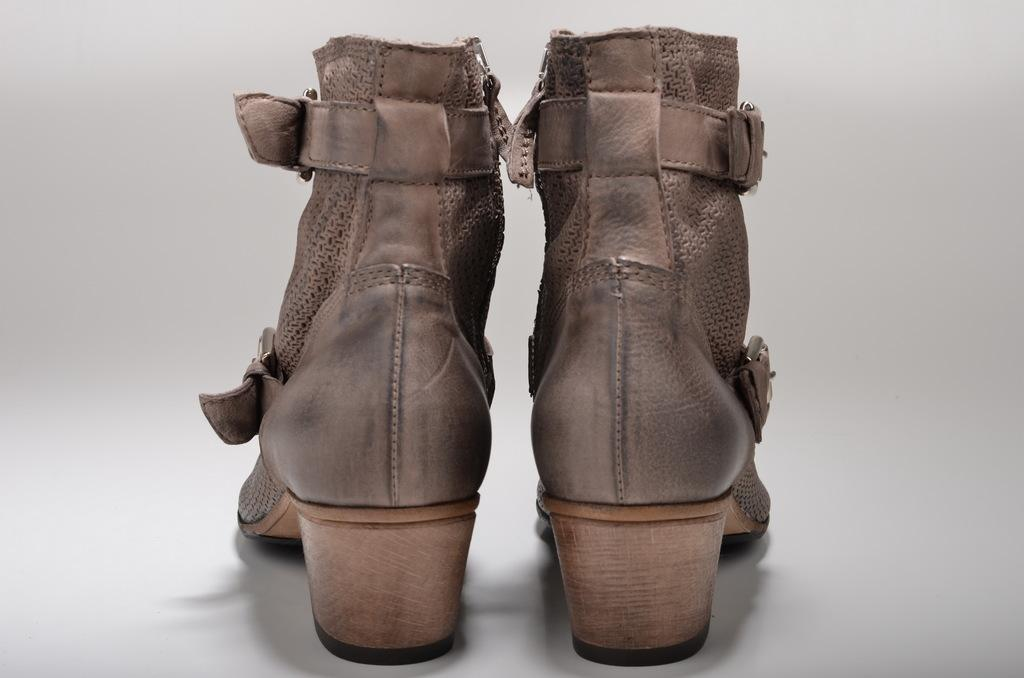What type of object is present in the image? There is footwear in the image. What color is the background of the image? The background of the image is white. How many bears are visible in the image? There are no bears present in the image. What type of farming equipment can be seen in the image? There is no farming equipment, such as a yoke, present in the image. 